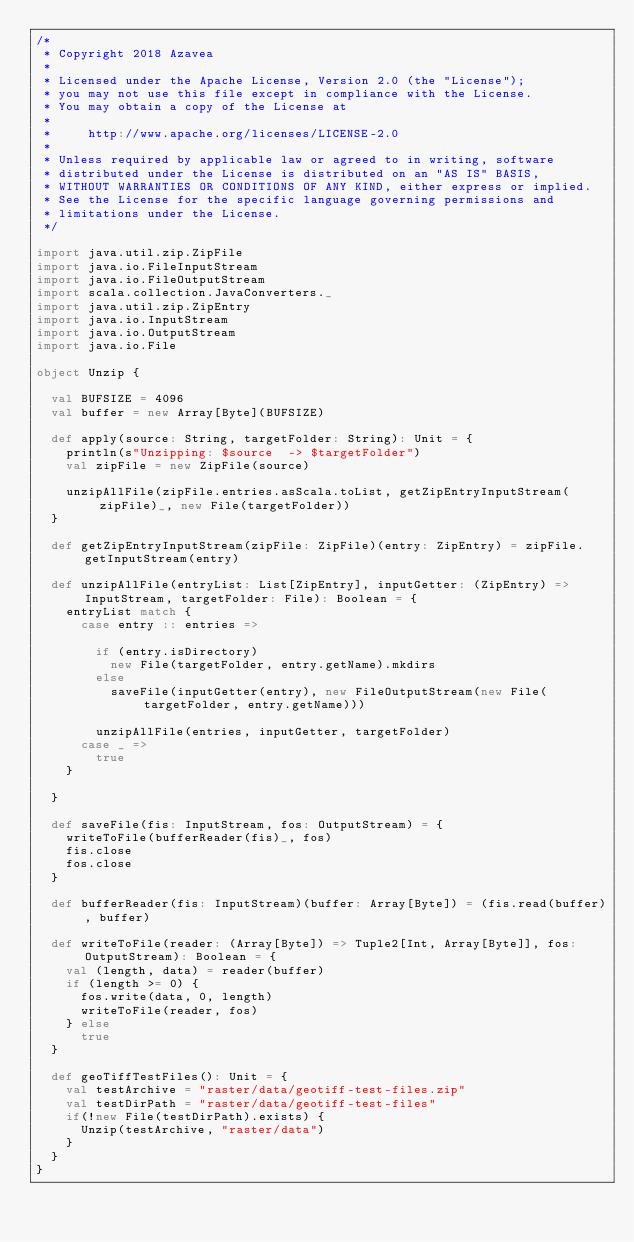Convert code to text. <code><loc_0><loc_0><loc_500><loc_500><_Scala_>/*
 * Copyright 2018 Azavea
 *
 * Licensed under the Apache License, Version 2.0 (the "License");
 * you may not use this file except in compliance with the License.
 * You may obtain a copy of the License at
 *
 *     http://www.apache.org/licenses/LICENSE-2.0
 *
 * Unless required by applicable law or agreed to in writing, software
 * distributed under the License is distributed on an "AS IS" BASIS,
 * WITHOUT WARRANTIES OR CONDITIONS OF ANY KIND, either express or implied.
 * See the License for the specific language governing permissions and
 * limitations under the License.
 */

import java.util.zip.ZipFile
import java.io.FileInputStream
import java.io.FileOutputStream
import scala.collection.JavaConverters._
import java.util.zip.ZipEntry
import java.io.InputStream
import java.io.OutputStream
import java.io.File

object Unzip {

  val BUFSIZE = 4096
  val buffer = new Array[Byte](BUFSIZE)
 
  def apply(source: String, targetFolder: String): Unit = {
    println(s"Unzipping: $source  -> $targetFolder")
    val zipFile = new ZipFile(source)
 
    unzipAllFile(zipFile.entries.asScala.toList, getZipEntryInputStream(zipFile)_, new File(targetFolder))
  }
 
  def getZipEntryInputStream(zipFile: ZipFile)(entry: ZipEntry) = zipFile.getInputStream(entry)
 
  def unzipAllFile(entryList: List[ZipEntry], inputGetter: (ZipEntry) => InputStream, targetFolder: File): Boolean = {    
    entryList match {
      case entry :: entries =>
 
        if (entry.isDirectory)
          new File(targetFolder, entry.getName).mkdirs
        else
          saveFile(inputGetter(entry), new FileOutputStream(new File(targetFolder, entry.getName)))
 
        unzipAllFile(entries, inputGetter, targetFolder)
      case _ =>
        true
    }
 
  }
  
  def saveFile(fis: InputStream, fos: OutputStream) = {
    writeToFile(bufferReader(fis)_, fos)
    fis.close
    fos.close
  }
 
  def bufferReader(fis: InputStream)(buffer: Array[Byte]) = (fis.read(buffer), buffer)
 
  def writeToFile(reader: (Array[Byte]) => Tuple2[Int, Array[Byte]], fos: OutputStream): Boolean = {
    val (length, data) = reader(buffer)
    if (length >= 0) {
      fos.write(data, 0, length)
      writeToFile(reader, fos)
    } else
      true
  }

  def geoTiffTestFiles(): Unit = {
    val testArchive = "raster/data/geotiff-test-files.zip"
    val testDirPath = "raster/data/geotiff-test-files"
    if(!new File(testDirPath).exists) {
      Unzip(testArchive, "raster/data")
    }
  }
}</code> 